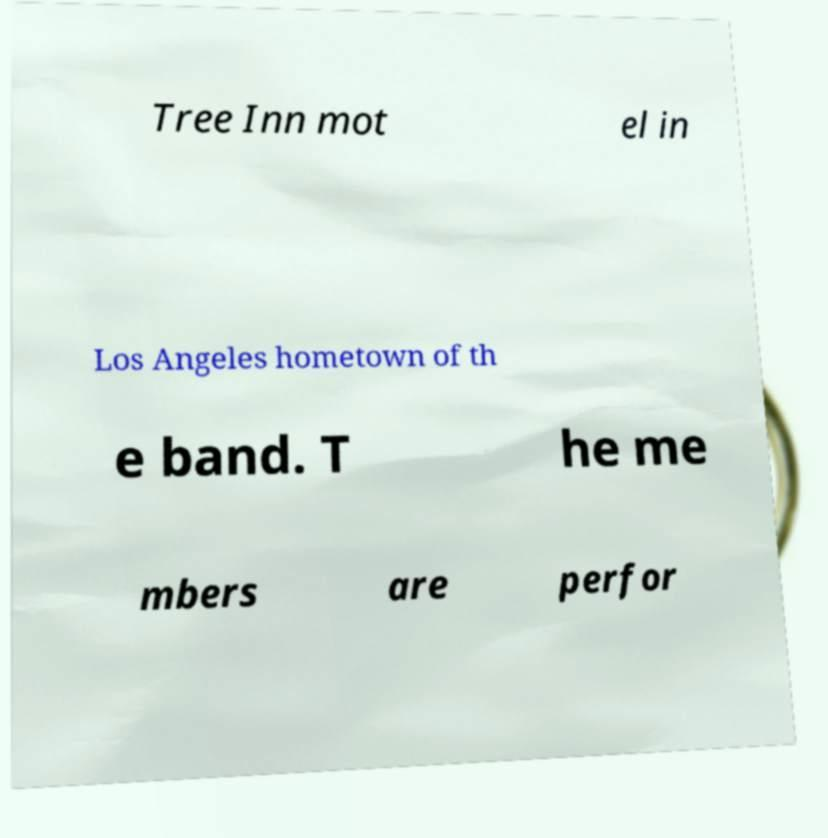For documentation purposes, I need the text within this image transcribed. Could you provide that? Tree Inn mot el in Los Angeles hometown of th e band. T he me mbers are perfor 